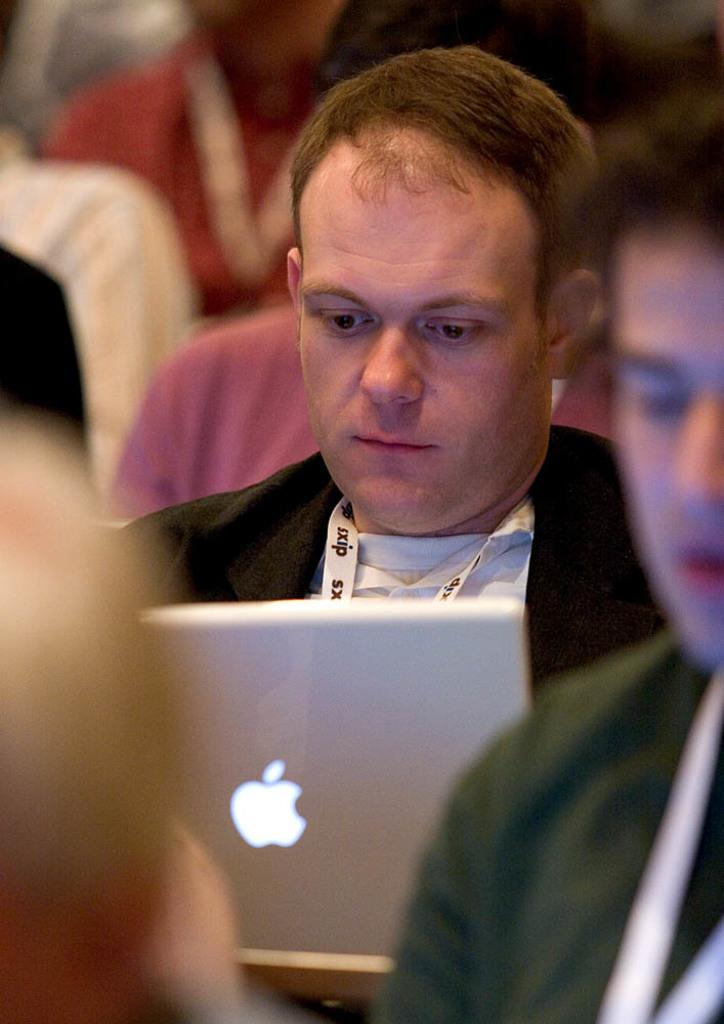Who is the main subject in the image? There is a man in the middle of the image. What is the man doing in the image? The man is looking at a laptop. Are there any other people present in the image? Yes, there are other people around the man. What family member is the creator of the laptop in the image? There is no information about the creator of the laptop in the image, nor is there any indication of a family member being present. 